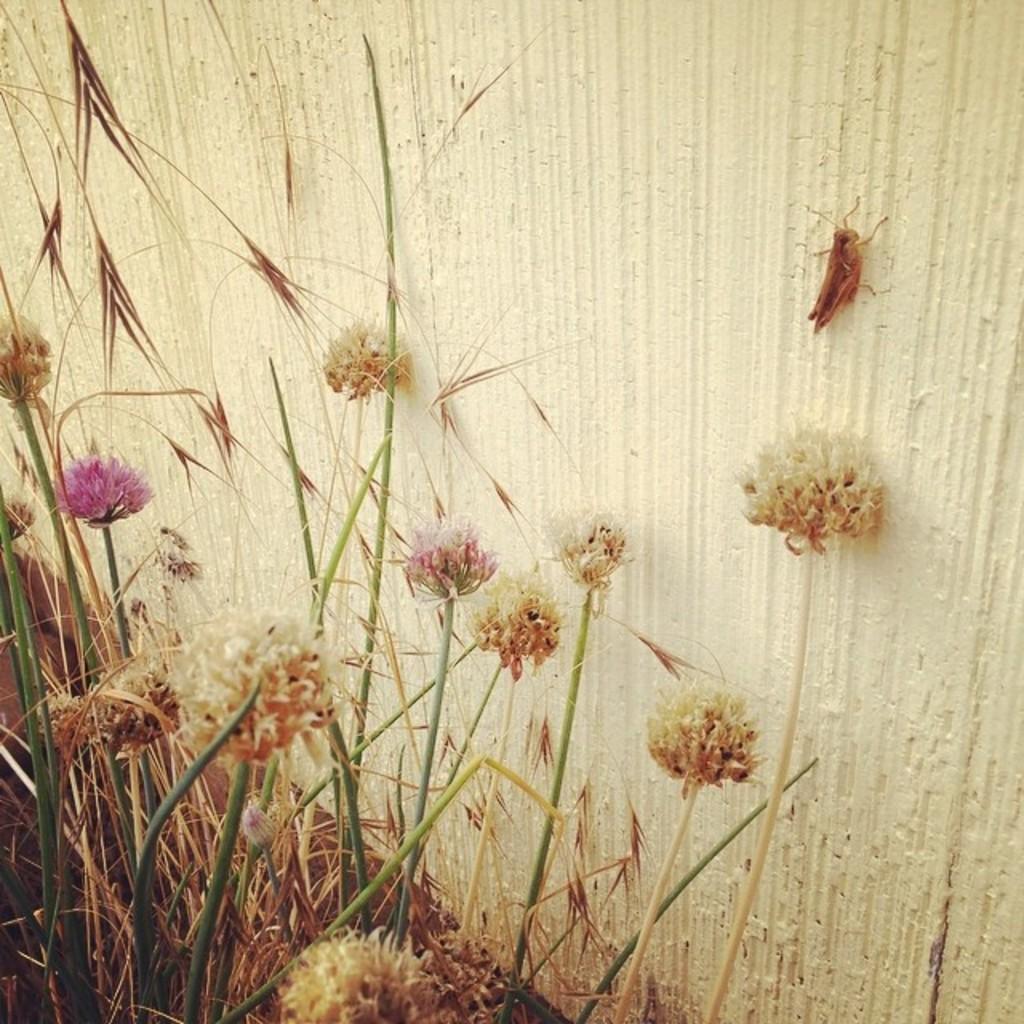Could you give a brief overview of what you see in this image? This image consists of so many flowers. There is grass at the bottom. There is a wall in the middle. 